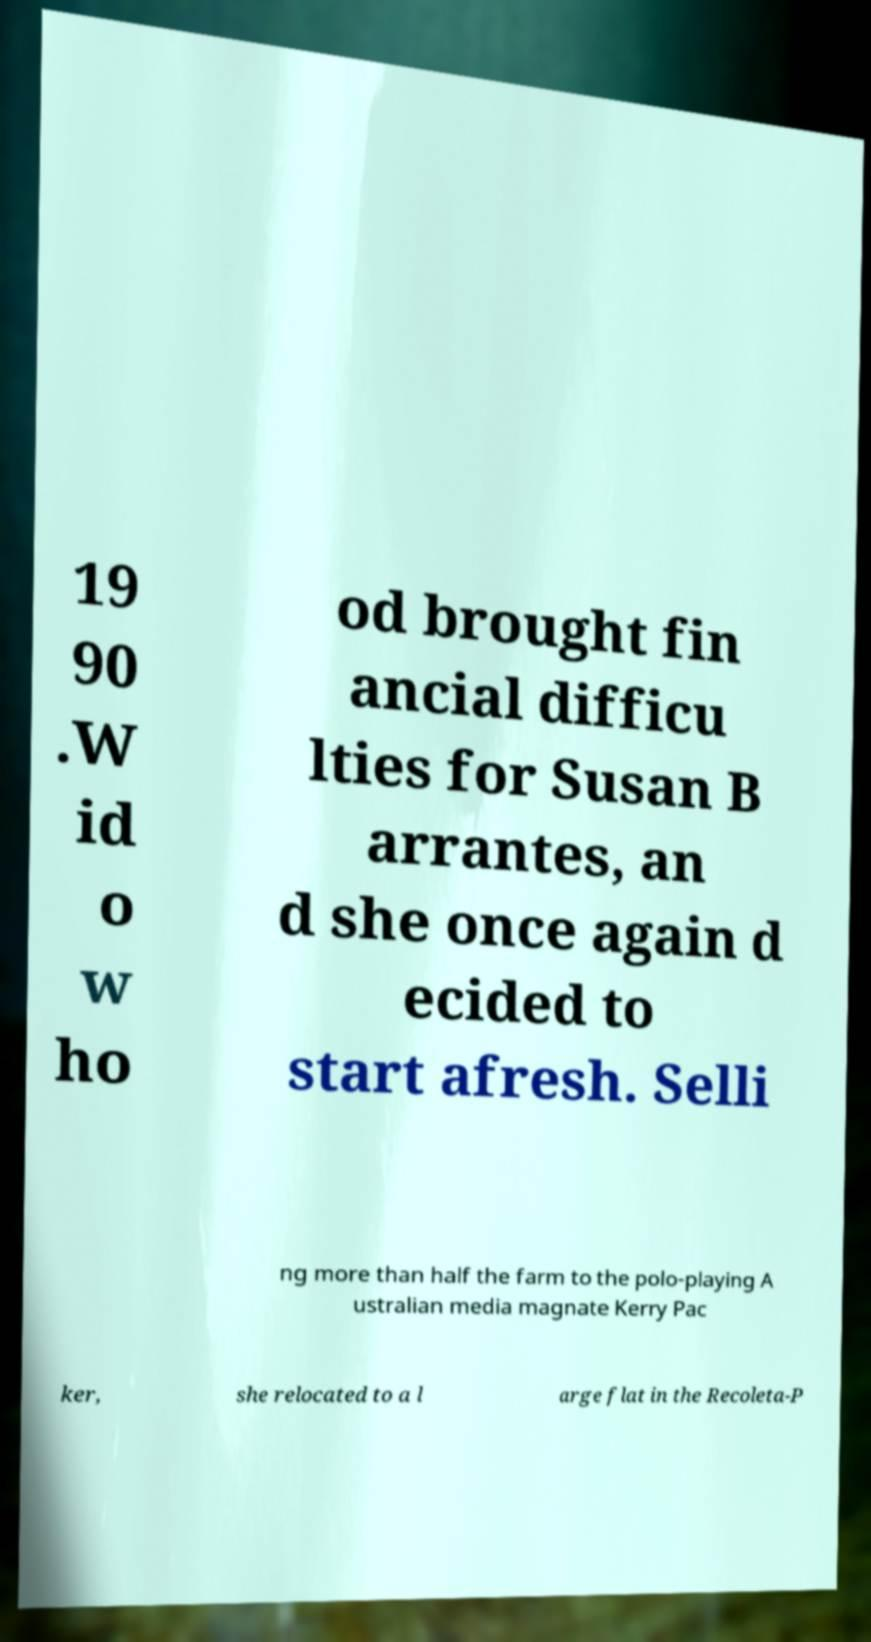Please read and relay the text visible in this image. What does it say? 19 90 .W id o w ho od brought fin ancial difficu lties for Susan B arrantes, an d she once again d ecided to start afresh. Selli ng more than half the farm to the polo-playing A ustralian media magnate Kerry Pac ker, she relocated to a l arge flat in the Recoleta-P 